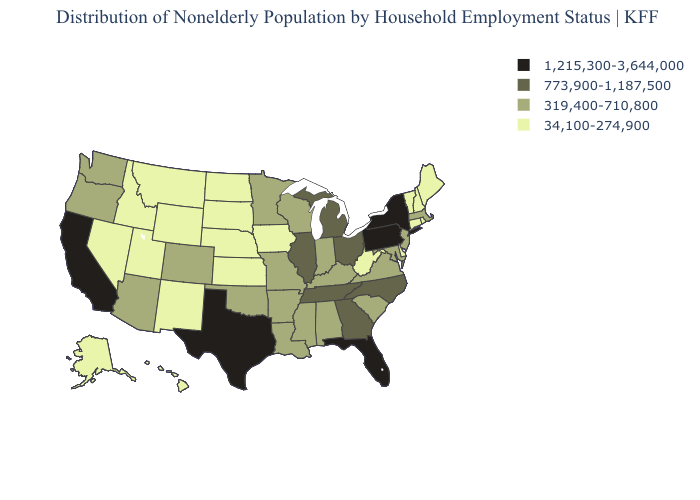What is the lowest value in states that border Arizona?
Short answer required. 34,100-274,900. Name the states that have a value in the range 319,400-710,800?
Short answer required. Alabama, Arizona, Arkansas, Colorado, Indiana, Kentucky, Louisiana, Maryland, Massachusetts, Minnesota, Mississippi, Missouri, New Jersey, Oklahoma, Oregon, South Carolina, Virginia, Washington, Wisconsin. Does Wyoming have a lower value than Maryland?
Short answer required. Yes. Name the states that have a value in the range 34,100-274,900?
Answer briefly. Alaska, Connecticut, Delaware, Hawaii, Idaho, Iowa, Kansas, Maine, Montana, Nebraska, Nevada, New Hampshire, New Mexico, North Dakota, Rhode Island, South Dakota, Utah, Vermont, West Virginia, Wyoming. Name the states that have a value in the range 34,100-274,900?
Answer briefly. Alaska, Connecticut, Delaware, Hawaii, Idaho, Iowa, Kansas, Maine, Montana, Nebraska, Nevada, New Hampshire, New Mexico, North Dakota, Rhode Island, South Dakota, Utah, Vermont, West Virginia, Wyoming. Does New York have the same value as California?
Write a very short answer. Yes. What is the highest value in the MidWest ?
Keep it brief. 773,900-1,187,500. Among the states that border Connecticut , which have the lowest value?
Answer briefly. Rhode Island. How many symbols are there in the legend?
Give a very brief answer. 4. Name the states that have a value in the range 1,215,300-3,644,000?
Short answer required. California, Florida, New York, Pennsylvania, Texas. Name the states that have a value in the range 773,900-1,187,500?
Short answer required. Georgia, Illinois, Michigan, North Carolina, Ohio, Tennessee. What is the value of Hawaii?
Give a very brief answer. 34,100-274,900. What is the lowest value in states that border Washington?
Concise answer only. 34,100-274,900. Does New Jersey have the lowest value in the USA?
Keep it brief. No. What is the highest value in the West ?
Short answer required. 1,215,300-3,644,000. 